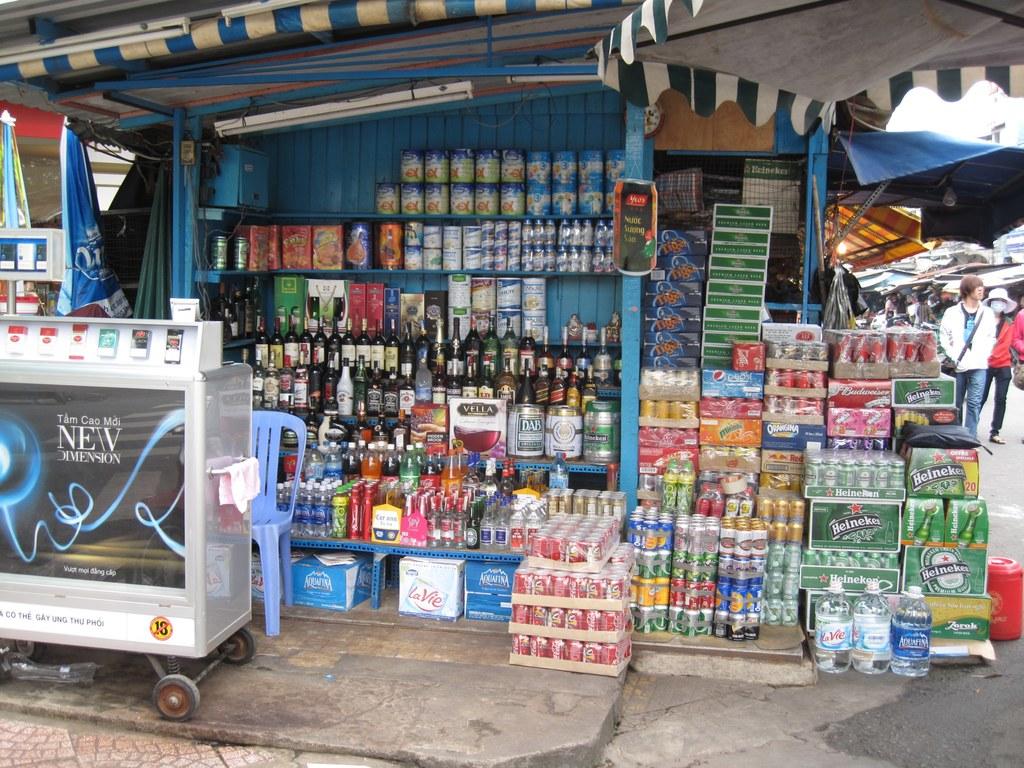What is the text on the counter?
Give a very brief answer. New. What kind of beer  can you see?
Ensure brevity in your answer.  Heineken. 